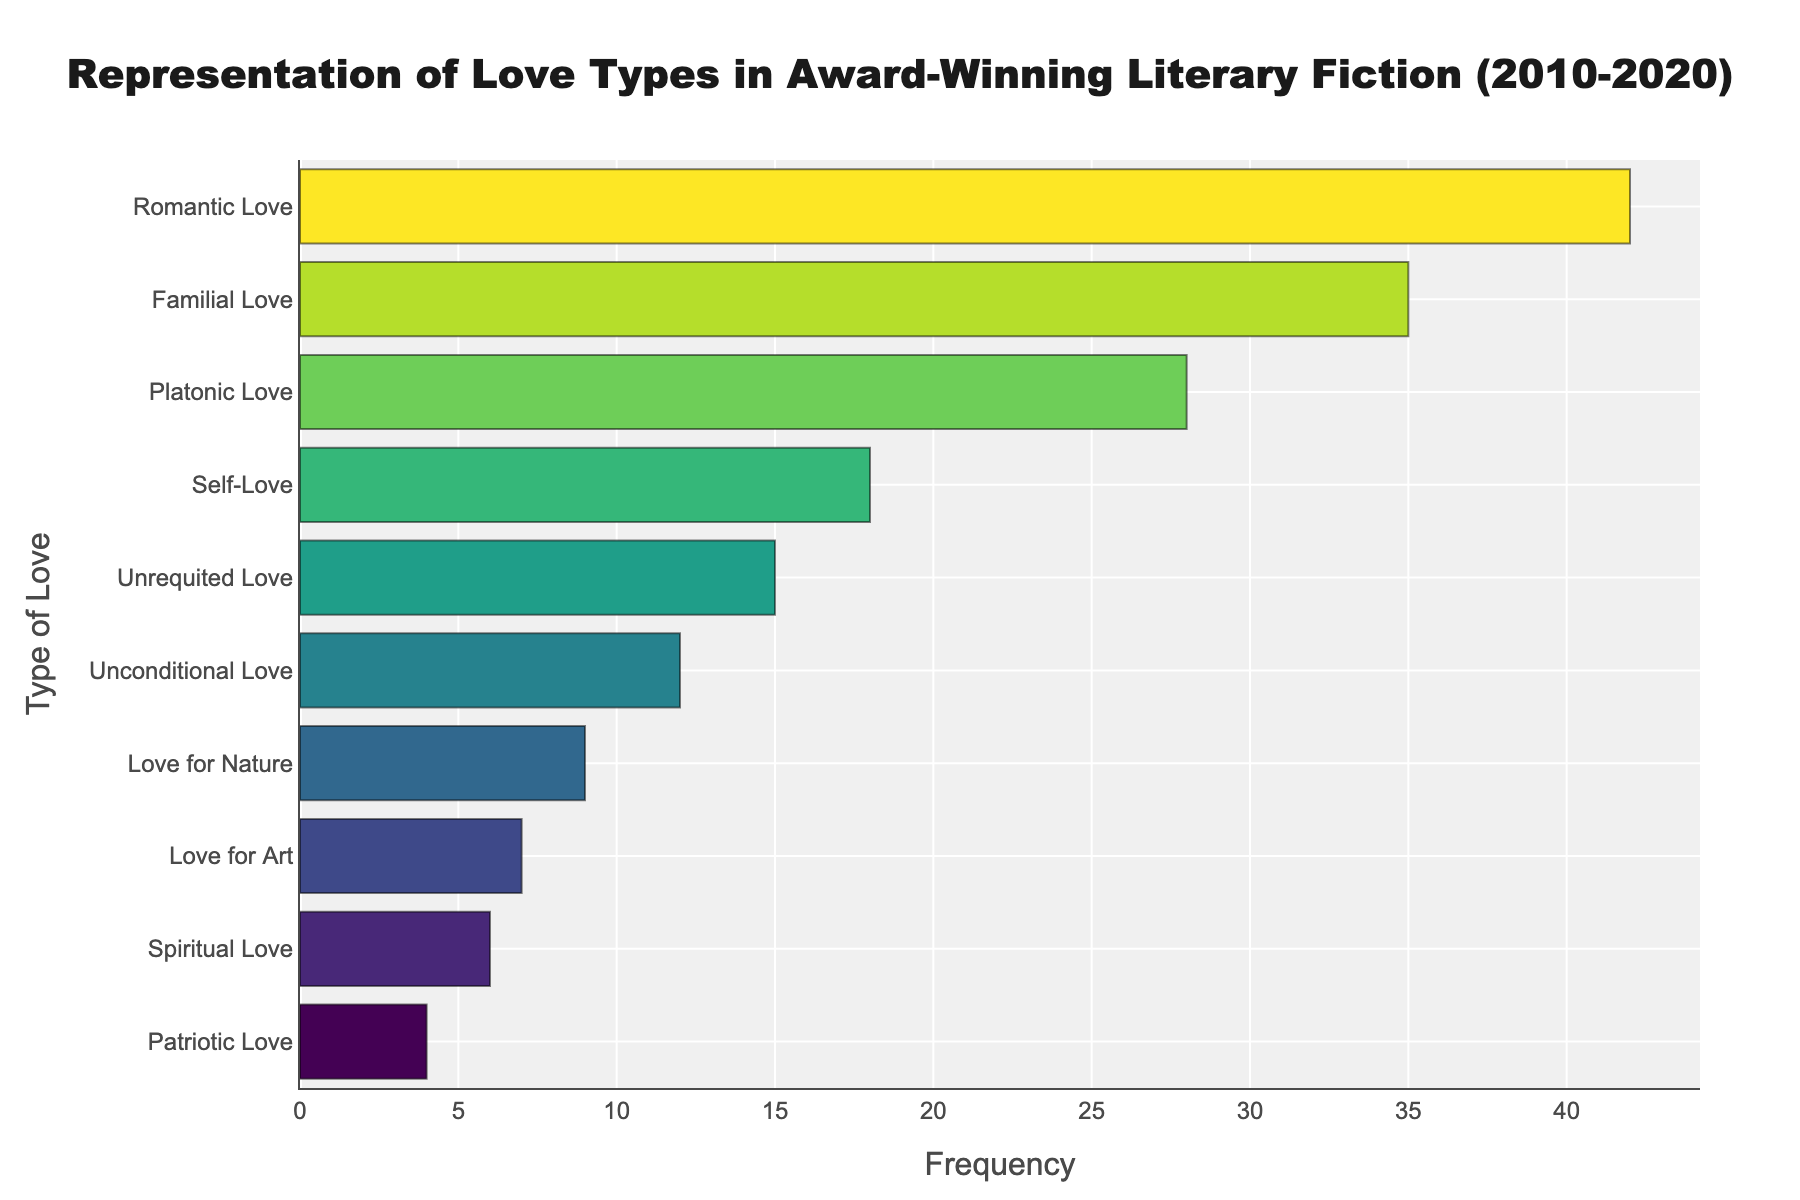Which type of love is represented the most in award-winning literary fiction? The bar for Romantic Love is the longest, indicating it has the highest frequency.
Answer: Romantic Love Which two types of love have frequencies closest to each other? The bars for Familial Love (35) and Platonic Love (28) appear to be closest in length among the pairs.
Answer: Familial Love and Platonic Love What is the combined frequency of Self-Love and Unrequited Love? The frequency for Self-Love is 18 and for Unrequited Love is 15. Adding them together gives 18 + 15 = 33.
Answer: 33 Is Unconditional Love represented more frequently than Love for Nature? The bar for Unconditional Love (12) is longer than the bar for Love for Nature (9), indicating a higher frequency.
Answer: Yes How does the frequency of Familial Love compare to Spiritual Love? Familial Love has a frequency of 35, whereas Spiritual Love has a frequency of 6. Therefore, Familial Love is represented more frequently.
Answer: Familial Love is represented more frequently Which type of love shows the lowest frequency in award-winning literary fiction? The shortest bar corresponds to Patriotic Love, indicating it has the lowest frequency of 4.
Answer: Patriotic Love What is the difference in frequency between Romantic Love and Platonic Love? Romantic Love has a frequency of 42 and Platonic Love has a frequency of 28. The difference is 42 - 28 = 14.
Answer: 14 What percentage of the total frequency do Unrequited Love and Love for Art represent together? The total frequency for all types of love is 42 + 35 + 28 + 18 + 15 + 12 + 9 + 7 + 6 + 4 = 176. The combined frequency for Unrequited Love and Love for Art is 15 + 7 = 22. The percentage is (22 / 176) * 100 ≈ 12.5%.
Answer: 12.5% What is the median frequency value of all the represented types of love? Sorting the frequencies yields: 4, 6, 7, 9, 12, 15, 18, 28, 35, 42. The median for 10 values (middle two) is (15 + 18)/2 = 16.5.
Answer: 16.5 Is the frequency of Love for Art higher than Love for Nature? The bar for Love for Nature (9) is longer than the bar for Love for Art (7), indicating Love for Art has a lower frequency.
Answer: No 